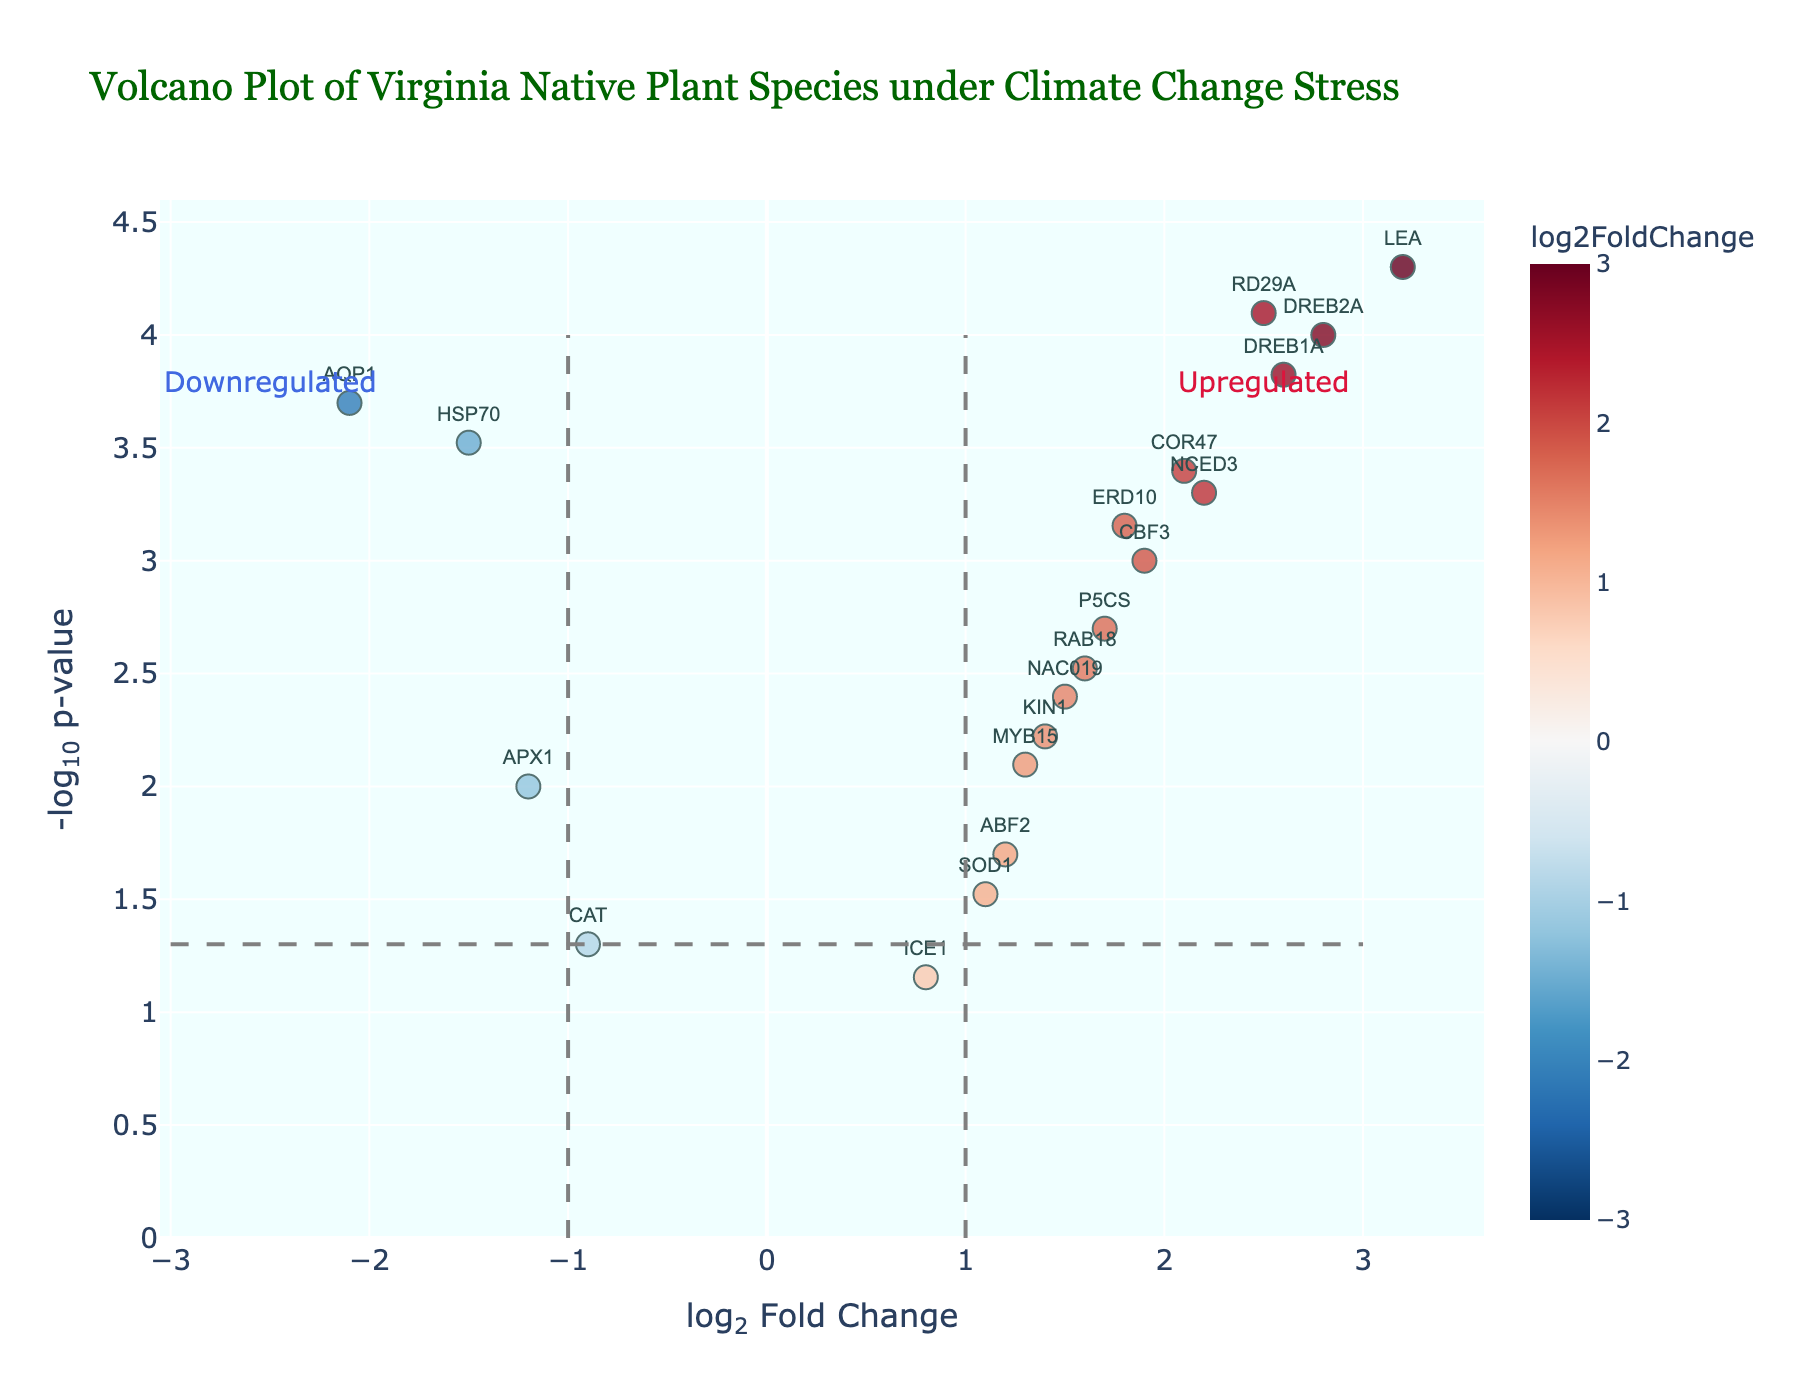What's the title of the figure? The title is prominently displayed at the top of the figure and usually provides a summary of what the plot is about.
Answer: Volcano Plot of Virginia Native Plant Species under Climate Change Stress What do the x-axis and y-axis represent in the figure? The x-axis represents the log2 Fold Change, which measures the magnitude of change in gene expression, while the y-axis represents the -log10 p-value, indicating the statistical significance of the change.
Answer: log2 Fold Change and -log10 p-value How many genes show a significant p-value below 0.05? Look for the number of data points above the horizontal dashed line, which marks the threshold for a p-value of 0.05 on the -log10(p-value) scale.
Answer: 18 genes Which gene has the highest log2 Fold Change and what is its value? Identify the gene with the highest position on the x-axis, which represents the log2 Fold Change.
Answer: LEA, 3.2 Is the gene ICE1 significantly upregulated? For a gene to be significantly upregulated, it should be on the right side of the vertical dashed line (x > 1) and above the horizontal dashed line (-log10(p-value) > 1.3). ICE1 falls to the left, indicating it is not significantly upregulated.
Answer: No Which gene shows the most significant change in expression under climate change stress? Identify the gene with the greatest y-axis value, which corresponds to the lowest p-value or highest -log10(p-value).
Answer: LEA How many genes are downregulated with a log2 Fold Change less than -1? Count the number of data points to the left of the vertical dashed line at -1 on the x-axis.
Answer: 3 genes Which upregulated gene has the smallest log2 Fold Change but still passes the p-value threshold? Look for an upregulated gene (x > 0) that is above the p-value threshold line but has the smallest x value.
Answer: SOD1 Are there more upregulated or downregulated genes with significant changes? Compare the number of data points to the right of the right vertical dashed line and left of the left vertical dashed line above the horizontal dashed line.
Answer: More upregulated genes What is the color scheme used, and what does it represent? The color scheme is a gradient from blue to red, representing the range of log2 Fold Change values from negative to positive.
Answer: RdBu_r, indicating log2 Fold Change 